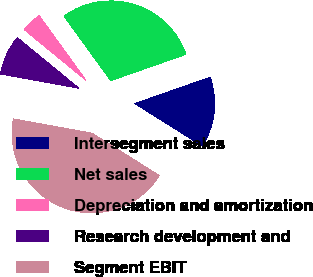Convert chart to OTSL. <chart><loc_0><loc_0><loc_500><loc_500><pie_chart><fcel>Intersegment sales<fcel>Net sales<fcel>Depreciation and amortization<fcel>Research development and<fcel>Segment EBIT<nl><fcel>14.3%<fcel>29.62%<fcel>4.09%<fcel>8.07%<fcel>43.92%<nl></chart> 